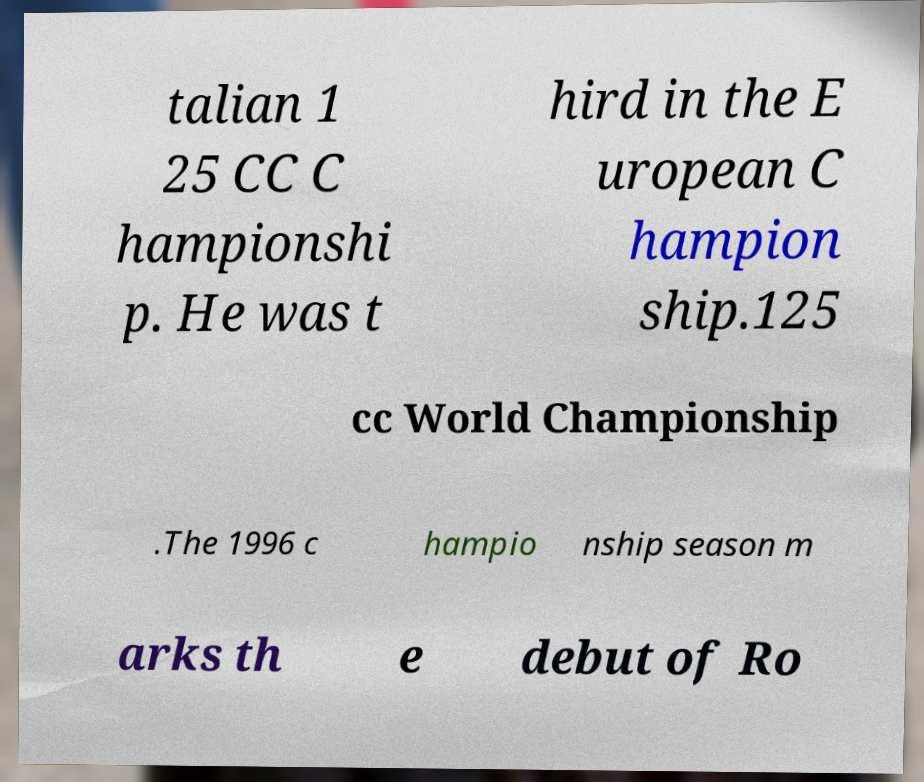I need the written content from this picture converted into text. Can you do that? talian 1 25 CC C hampionshi p. He was t hird in the E uropean C hampion ship.125 cc World Championship .The 1996 c hampio nship season m arks th e debut of Ro 